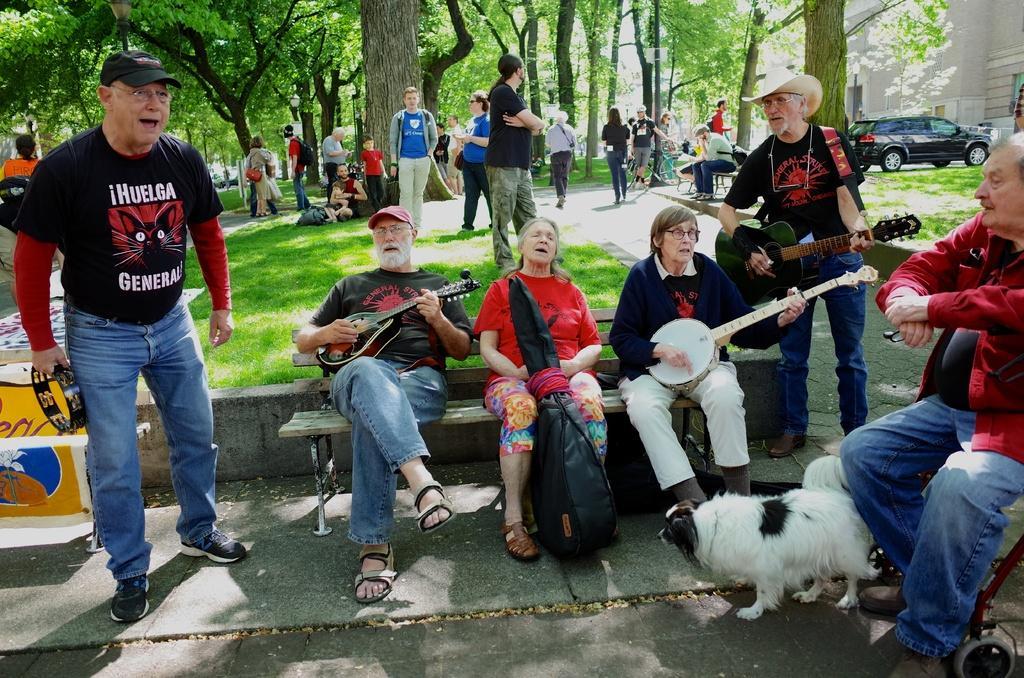Please provide a concise description of this image. There are many people sitting and standing and playing musical instruments. There is a puppy in the front. Three persons are sitting on the bench In the back there is a grass lawn. Also there are many people sitting and walking on the road. In the right side there is a car and a building. There are many trees in the background. A person in the left is wearing a cap. 